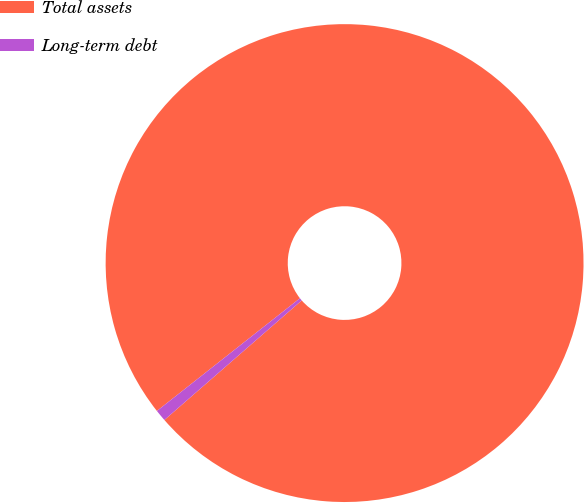Convert chart. <chart><loc_0><loc_0><loc_500><loc_500><pie_chart><fcel>Total assets<fcel>Long-term debt<nl><fcel>99.22%<fcel>0.78%<nl></chart> 